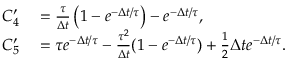<formula> <loc_0><loc_0><loc_500><loc_500>\begin{array} { r l } { C _ { 4 } ^ { \prime } } & = \frac { \tau } { \Delta t } \left ( 1 - e ^ { - \Delta t / \tau } \right ) - e ^ { - \Delta t / \tau } , } \\ { C _ { 5 } ^ { \prime } } & = \tau e ^ { - \Delta t / \tau } - \frac { \tau ^ { 2 } } { \Delta t } ( 1 - e ^ { - \Delta t / \tau } ) + \frac { 1 } { 2 } \Delta t e ^ { - \Delta t / \tau } . } \end{array}</formula> 